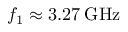Convert formula to latex. <formula><loc_0><loc_0><loc_500><loc_500>f _ { 1 } \approx 3 . 2 7 \, G H z</formula> 